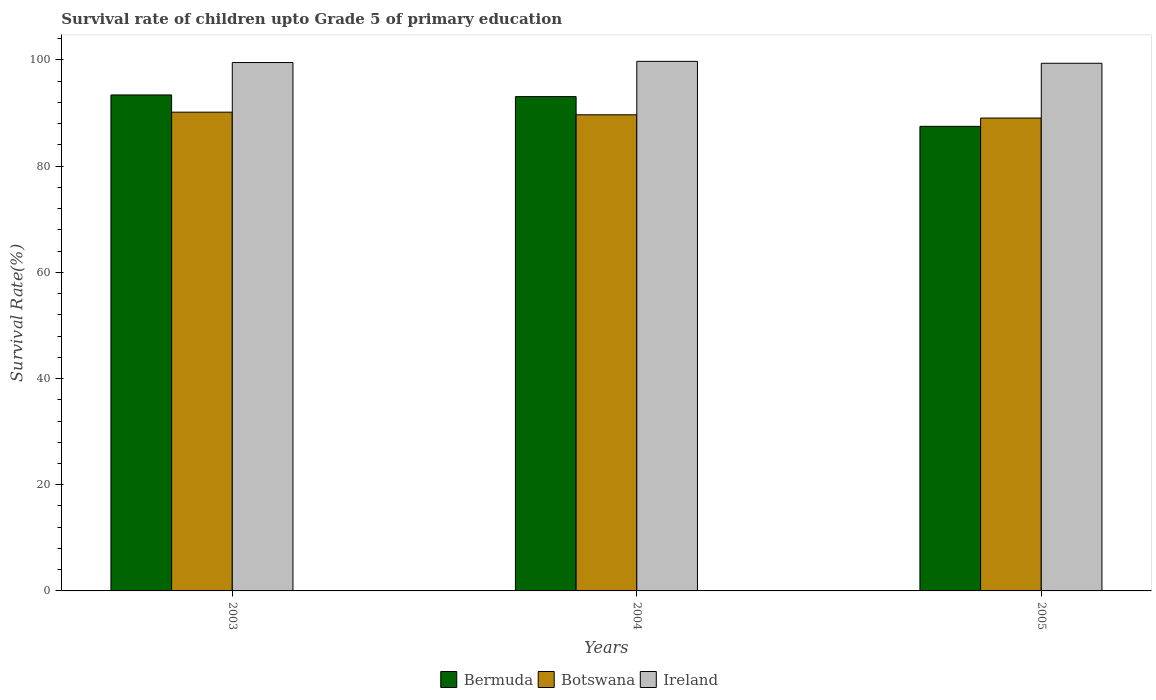How many groups of bars are there?
Offer a terse response. 3. Are the number of bars on each tick of the X-axis equal?
Give a very brief answer. Yes. How many bars are there on the 2nd tick from the right?
Your answer should be very brief. 3. What is the label of the 3rd group of bars from the left?
Keep it short and to the point. 2005. In how many cases, is the number of bars for a given year not equal to the number of legend labels?
Your answer should be compact. 0. What is the survival rate of children in Bermuda in 2005?
Keep it short and to the point. 87.5. Across all years, what is the maximum survival rate of children in Bermuda?
Provide a succinct answer. 93.41. Across all years, what is the minimum survival rate of children in Ireland?
Offer a very short reply. 99.37. In which year was the survival rate of children in Botswana maximum?
Your answer should be very brief. 2003. What is the total survival rate of children in Ireland in the graph?
Your answer should be compact. 298.62. What is the difference between the survival rate of children in Ireland in 2003 and that in 2004?
Keep it short and to the point. -0.22. What is the difference between the survival rate of children in Bermuda in 2005 and the survival rate of children in Botswana in 2004?
Offer a terse response. -2.18. What is the average survival rate of children in Bermuda per year?
Your response must be concise. 91.33. In the year 2005, what is the difference between the survival rate of children in Ireland and survival rate of children in Bermuda?
Make the answer very short. 11.88. In how many years, is the survival rate of children in Bermuda greater than 8 %?
Your response must be concise. 3. What is the ratio of the survival rate of children in Ireland in 2004 to that in 2005?
Your response must be concise. 1. Is the survival rate of children in Botswana in 2004 less than that in 2005?
Your answer should be compact. No. What is the difference between the highest and the second highest survival rate of children in Ireland?
Offer a very short reply. 0.22. What is the difference between the highest and the lowest survival rate of children in Botswana?
Your answer should be compact. 1.11. What does the 1st bar from the left in 2004 represents?
Your answer should be compact. Bermuda. What does the 2nd bar from the right in 2004 represents?
Give a very brief answer. Botswana. Is it the case that in every year, the sum of the survival rate of children in Botswana and survival rate of children in Bermuda is greater than the survival rate of children in Ireland?
Offer a terse response. Yes. How many bars are there?
Make the answer very short. 9. Are all the bars in the graph horizontal?
Ensure brevity in your answer.  No. Does the graph contain any zero values?
Offer a terse response. No. What is the title of the graph?
Offer a terse response. Survival rate of children upto Grade 5 of primary education. What is the label or title of the X-axis?
Make the answer very short. Years. What is the label or title of the Y-axis?
Your answer should be very brief. Survival Rate(%). What is the Survival Rate(%) in Bermuda in 2003?
Make the answer very short. 93.41. What is the Survival Rate(%) of Botswana in 2003?
Offer a very short reply. 90.17. What is the Survival Rate(%) of Ireland in 2003?
Provide a succinct answer. 99.51. What is the Survival Rate(%) of Bermuda in 2004?
Offer a terse response. 93.1. What is the Survival Rate(%) of Botswana in 2004?
Provide a succinct answer. 89.67. What is the Survival Rate(%) in Ireland in 2004?
Your answer should be compact. 99.74. What is the Survival Rate(%) of Bermuda in 2005?
Ensure brevity in your answer.  87.5. What is the Survival Rate(%) of Botswana in 2005?
Give a very brief answer. 89.06. What is the Survival Rate(%) in Ireland in 2005?
Make the answer very short. 99.37. Across all years, what is the maximum Survival Rate(%) in Bermuda?
Provide a short and direct response. 93.41. Across all years, what is the maximum Survival Rate(%) in Botswana?
Your answer should be compact. 90.17. Across all years, what is the maximum Survival Rate(%) of Ireland?
Provide a short and direct response. 99.74. Across all years, what is the minimum Survival Rate(%) in Bermuda?
Your answer should be compact. 87.5. Across all years, what is the minimum Survival Rate(%) in Botswana?
Make the answer very short. 89.06. Across all years, what is the minimum Survival Rate(%) in Ireland?
Ensure brevity in your answer.  99.37. What is the total Survival Rate(%) in Bermuda in the graph?
Your answer should be very brief. 274. What is the total Survival Rate(%) of Botswana in the graph?
Offer a terse response. 268.89. What is the total Survival Rate(%) of Ireland in the graph?
Provide a succinct answer. 298.62. What is the difference between the Survival Rate(%) of Bermuda in 2003 and that in 2004?
Keep it short and to the point. 0.32. What is the difference between the Survival Rate(%) of Botswana in 2003 and that in 2004?
Offer a very short reply. 0.5. What is the difference between the Survival Rate(%) of Ireland in 2003 and that in 2004?
Offer a very short reply. -0.22. What is the difference between the Survival Rate(%) of Bermuda in 2003 and that in 2005?
Give a very brief answer. 5.92. What is the difference between the Survival Rate(%) in Botswana in 2003 and that in 2005?
Ensure brevity in your answer.  1.11. What is the difference between the Survival Rate(%) of Ireland in 2003 and that in 2005?
Make the answer very short. 0.14. What is the difference between the Survival Rate(%) of Bermuda in 2004 and that in 2005?
Provide a succinct answer. 5.6. What is the difference between the Survival Rate(%) of Botswana in 2004 and that in 2005?
Offer a very short reply. 0.61. What is the difference between the Survival Rate(%) of Ireland in 2004 and that in 2005?
Offer a very short reply. 0.36. What is the difference between the Survival Rate(%) in Bermuda in 2003 and the Survival Rate(%) in Botswana in 2004?
Keep it short and to the point. 3.74. What is the difference between the Survival Rate(%) in Bermuda in 2003 and the Survival Rate(%) in Ireland in 2004?
Provide a short and direct response. -6.33. What is the difference between the Survival Rate(%) of Botswana in 2003 and the Survival Rate(%) of Ireland in 2004?
Make the answer very short. -9.57. What is the difference between the Survival Rate(%) of Bermuda in 2003 and the Survival Rate(%) of Botswana in 2005?
Make the answer very short. 4.36. What is the difference between the Survival Rate(%) of Bermuda in 2003 and the Survival Rate(%) of Ireland in 2005?
Make the answer very short. -5.96. What is the difference between the Survival Rate(%) of Botswana in 2003 and the Survival Rate(%) of Ireland in 2005?
Your response must be concise. -9.21. What is the difference between the Survival Rate(%) in Bermuda in 2004 and the Survival Rate(%) in Botswana in 2005?
Your answer should be very brief. 4.04. What is the difference between the Survival Rate(%) in Bermuda in 2004 and the Survival Rate(%) in Ireland in 2005?
Offer a terse response. -6.28. What is the difference between the Survival Rate(%) of Botswana in 2004 and the Survival Rate(%) of Ireland in 2005?
Offer a terse response. -9.7. What is the average Survival Rate(%) of Bermuda per year?
Your response must be concise. 91.33. What is the average Survival Rate(%) in Botswana per year?
Ensure brevity in your answer.  89.63. What is the average Survival Rate(%) in Ireland per year?
Keep it short and to the point. 99.54. In the year 2003, what is the difference between the Survival Rate(%) in Bermuda and Survival Rate(%) in Botswana?
Offer a terse response. 3.24. In the year 2003, what is the difference between the Survival Rate(%) in Bermuda and Survival Rate(%) in Ireland?
Provide a short and direct response. -6.1. In the year 2003, what is the difference between the Survival Rate(%) of Botswana and Survival Rate(%) of Ireland?
Provide a short and direct response. -9.35. In the year 2004, what is the difference between the Survival Rate(%) of Bermuda and Survival Rate(%) of Botswana?
Provide a succinct answer. 3.42. In the year 2004, what is the difference between the Survival Rate(%) of Bermuda and Survival Rate(%) of Ireland?
Keep it short and to the point. -6.64. In the year 2004, what is the difference between the Survival Rate(%) of Botswana and Survival Rate(%) of Ireland?
Your answer should be compact. -10.07. In the year 2005, what is the difference between the Survival Rate(%) of Bermuda and Survival Rate(%) of Botswana?
Your response must be concise. -1.56. In the year 2005, what is the difference between the Survival Rate(%) in Bermuda and Survival Rate(%) in Ireland?
Provide a succinct answer. -11.88. In the year 2005, what is the difference between the Survival Rate(%) of Botswana and Survival Rate(%) of Ireland?
Ensure brevity in your answer.  -10.32. What is the ratio of the Survival Rate(%) in Botswana in 2003 to that in 2004?
Your answer should be very brief. 1.01. What is the ratio of the Survival Rate(%) in Bermuda in 2003 to that in 2005?
Ensure brevity in your answer.  1.07. What is the ratio of the Survival Rate(%) of Botswana in 2003 to that in 2005?
Give a very brief answer. 1.01. What is the ratio of the Survival Rate(%) in Ireland in 2003 to that in 2005?
Keep it short and to the point. 1. What is the ratio of the Survival Rate(%) of Bermuda in 2004 to that in 2005?
Offer a terse response. 1.06. What is the ratio of the Survival Rate(%) of Botswana in 2004 to that in 2005?
Provide a succinct answer. 1.01. What is the ratio of the Survival Rate(%) of Ireland in 2004 to that in 2005?
Your answer should be very brief. 1. What is the difference between the highest and the second highest Survival Rate(%) in Bermuda?
Your answer should be compact. 0.32. What is the difference between the highest and the second highest Survival Rate(%) in Botswana?
Give a very brief answer. 0.5. What is the difference between the highest and the second highest Survival Rate(%) of Ireland?
Make the answer very short. 0.22. What is the difference between the highest and the lowest Survival Rate(%) of Bermuda?
Provide a succinct answer. 5.92. What is the difference between the highest and the lowest Survival Rate(%) in Botswana?
Give a very brief answer. 1.11. What is the difference between the highest and the lowest Survival Rate(%) in Ireland?
Provide a short and direct response. 0.36. 